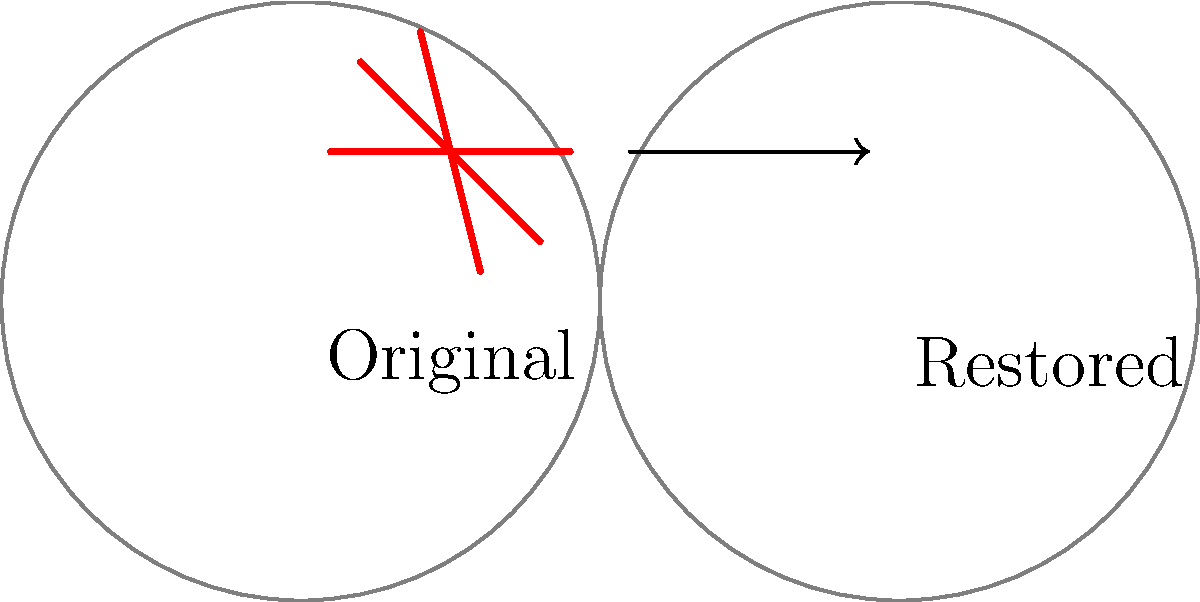In the image restoration process shown above, which technique would be most effective for removing the linear scratches while preserving the underlying image details? To effectively remove the linear scratches while preserving underlying image details, we should consider the following steps:

1. Analyze the nature of the scratches: The scratches appear as thin, straight lines across the image.

2. Identify the appropriate technique: For linear scratches, the most effective technique is often the "clone stamp" or "healing brush" tool.

3. Understanding the clone stamp/healing brush:
   a. These tools allow you to sample undamaged areas of the image.
   b. You can then "paint" over the damaged areas with the sampled data.

4. Application process:
   a. Select a source area close to the scratch that matches the surrounding texture and color.
   b. Carefully apply the tool along the length of each scratch.
   c. Blend the edges of the repaired area to seamlessly integrate with the surrounding image.

5. Advantages of this technique:
   a. Preserves the original texture and details of the image.
   b. Allows for precise control over the restoration process.
   c. Can be applied selectively, only affecting the damaged areas.

6. Alternative techniques like simple blurring or content-aware fill might remove the scratches but could also degrade image quality or introduce unwanted artifacts.

Given these considerations, the clone stamp or healing brush technique would be most effective for this specific type of damage.
Answer: Clone stamp or healing brush 